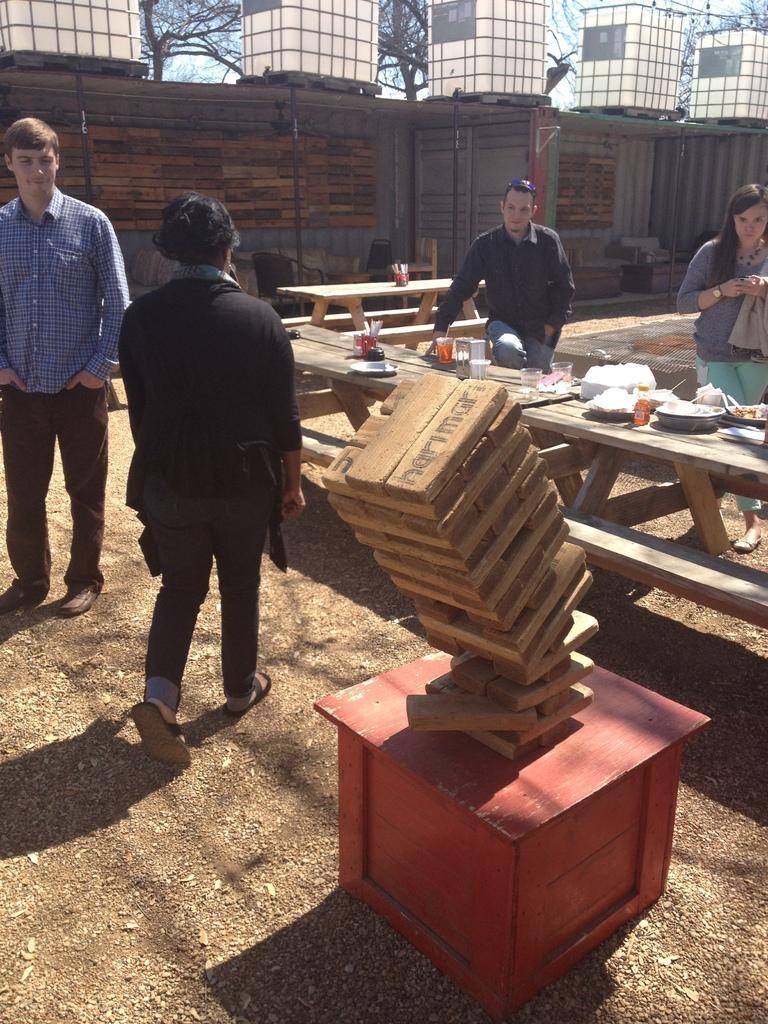Can you describe this image briefly? In this image we can see four persons. Beside the persons we can see few objects on a table. Behind the persons we can see the chairs and a wall. At the top we can see the sky and the trees. In the foreground there are wooden blocks on a table. 